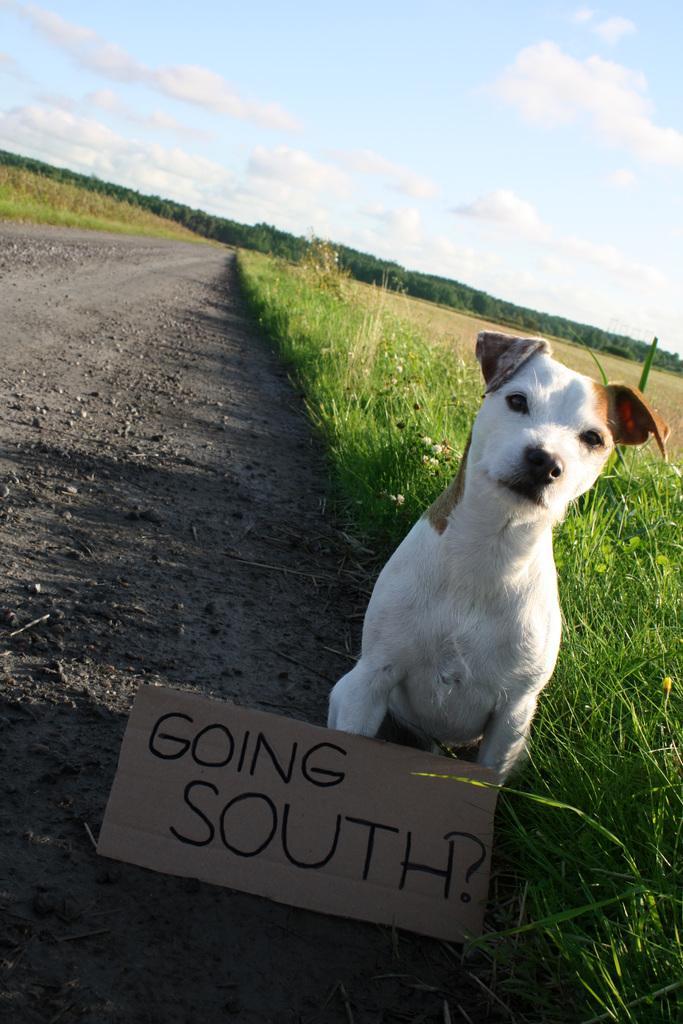In one or two sentences, can you explain what this image depicts? There is a dog and text on cardboard in the foreground area of the image, there are trees, grassland and the sky in the background. 